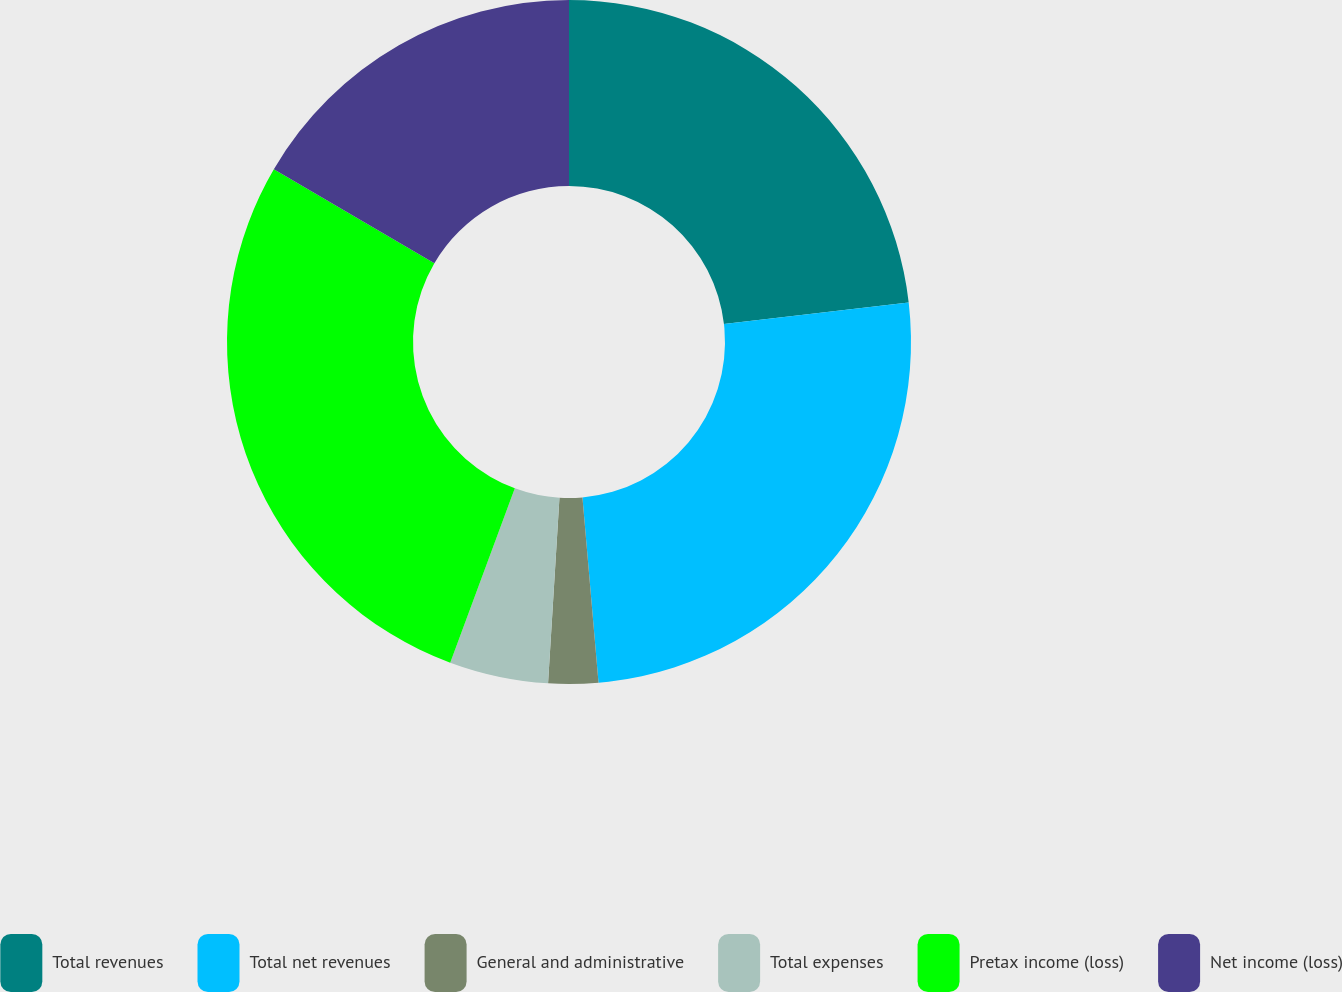<chart> <loc_0><loc_0><loc_500><loc_500><pie_chart><fcel>Total revenues<fcel>Total net revenues<fcel>General and administrative<fcel>Total expenses<fcel>Pretax income (loss)<fcel>Net income (loss)<nl><fcel>23.15%<fcel>25.47%<fcel>2.35%<fcel>4.67%<fcel>27.78%<fcel>16.57%<nl></chart> 